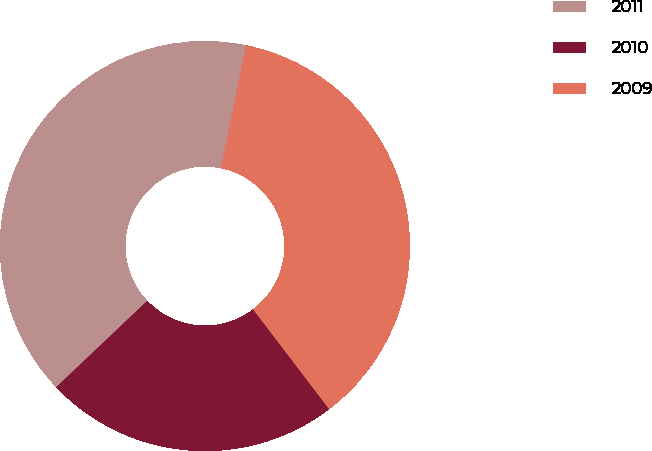<chart> <loc_0><loc_0><loc_500><loc_500><pie_chart><fcel>2011<fcel>2010<fcel>2009<nl><fcel>40.29%<fcel>23.28%<fcel>36.42%<nl></chart> 